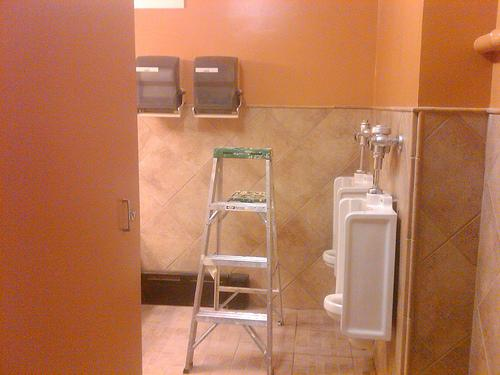Describe the presence and elements of any door in this image. There's an open orange bathroom door on the left, with a silver door pull handle and lock, revealing its handle and lock. Explain the possible purpose of the ladder in the image. The short aluminum ladder, situated in front of the urinals, is likely for repairing or maintaining the bathroom fixtures. Point out the locations of the available means to clean visitors' hands. There are two paper towel dispensers on the left wall, one near the step ladder and another to the left of it. List the significant objects visible in the image, arranged from left to right. Open orange door with handle, paper towel dispensers, black box against the wall, green-top aluminum ladder, white porcelain urinals, and chrome flush valves. Write a descriptive sentence about the bathroom's floor and wall composition. The bathroom features shiny ceramic tile on the walls and an intricate pattern of rounded tile border on the floor, with a visible crack between the tiles. Identify the unusual object in the image and its position. A dark brown rectangle-shaped object against the left wall under the paper towel dispensers. Provide a brief summary of the essential elements in the image. A bathroom with two urinals, paper towel dispensers, an open orange door with a handle, a short aluminum ladder, and a mysterious dark brown object against the wall. Mention the color and position of the primary objects in the image. In a bathroom, there is a green top ladder in front of white urinals, a black object under the brown paper towel dispensers on the left wall, and an orange open door on the left. Mention the objects related to personal hygiene in the image. Two white porcelain urinals with chrome flush valves, and two paper towel dispensers on the wall. Describe the on-going activities in the image, if any. Maintenance work seems to be in progress in a men's bathroom, with a short aluminum ladder set up in front of the urinals and an open door. 